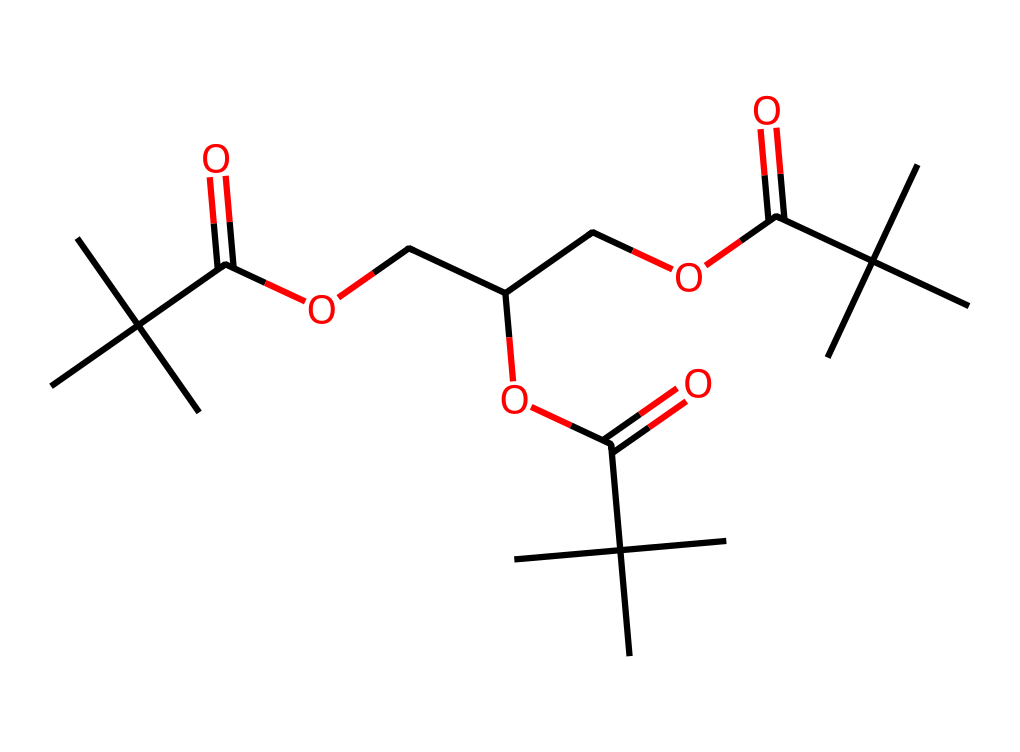what is the molecular formula of the chemical represented? To deduce the molecular formula, we count the total number of each type of atom in the given SMILES representation. By analyzing it, we find there are 27 carbon atoms, 50 hydrogen atoms, and 6 oxygen atoms, leading to the formula C27H50O6.
Answer: C27H50O6 how many ester functional groups are present in this chemical? Esters are characterized by the presence of -COO- groups. By examining the structure represented by the SMILES, we can identify three -COO- groups, indicating that there are three ester functional groups in this chemical.
Answer: 3 what type of polymer can be formed from this chemical? This chemical contains photoactive components which are characteristic of photoresists. This suggests that upon exposure to light, it can undergo polymerization, thus forming polymers suitable for use in creating replica moldings.
Answer: photoresist what is the role of the ester groups in the properties of this chemical? The ester groups contribute to the flexibility and processability of the polymer. They can also influence the solubility and reactivity under UV light, which is essential for photopolymer applications in mold making.
Answer: flexibility is this chemical likely to be soluble in organic solvents? Since the chemical has multiple ester groups and a substantial hydrocarbon backbone, it is generally expected to have good solubility in organic solvents due to its polar and non-polar characteristics allowing for interactions with various solvents.
Answer: yes 